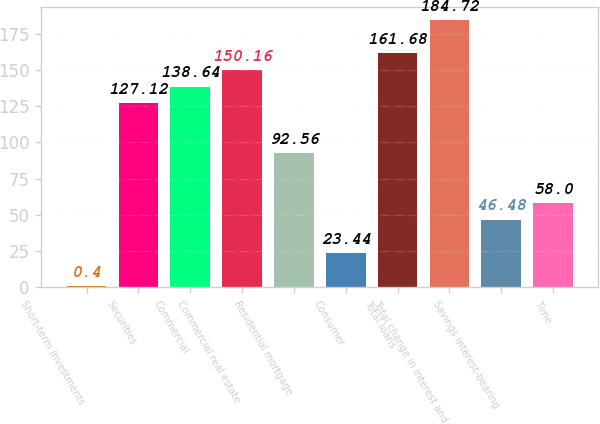Convert chart. <chart><loc_0><loc_0><loc_500><loc_500><bar_chart><fcel>Short-term investments<fcel>Securities<fcel>Commercial<fcel>Commercial real estate<fcel>Residential mortgage<fcel>Consumer<fcel>Total loans<fcel>Total change in interest and<fcel>Savings interest-bearing<fcel>Time<nl><fcel>0.4<fcel>127.12<fcel>138.64<fcel>150.16<fcel>92.56<fcel>23.44<fcel>161.68<fcel>184.72<fcel>46.48<fcel>58<nl></chart> 